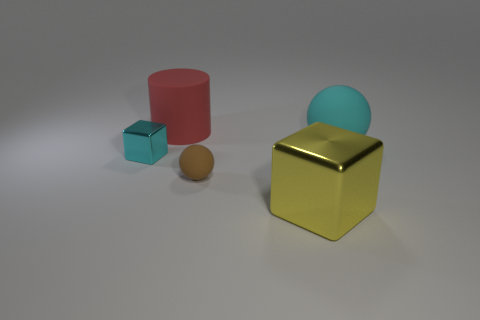How many other things are the same size as the red matte object?
Give a very brief answer. 2. The rubber cylinder is what color?
Offer a terse response. Red. Does the metal block on the left side of the brown ball have the same color as the small rubber ball in front of the big cylinder?
Make the answer very short. No. What size is the red rubber cylinder?
Ensure brevity in your answer.  Large. There is a cyan object that is left of the cyan sphere; what size is it?
Your answer should be compact. Small. There is a object that is both behind the yellow block and right of the small brown matte sphere; what is its shape?
Offer a very short reply. Sphere. How many other things are the same shape as the cyan metallic thing?
Provide a short and direct response. 1. What color is the rubber object that is the same size as the rubber cylinder?
Your answer should be compact. Cyan. How many things are either big metallic cubes or tiny purple metallic spheres?
Keep it short and to the point. 1. There is a large cyan sphere; are there any tiny metal cubes behind it?
Keep it short and to the point. No. 